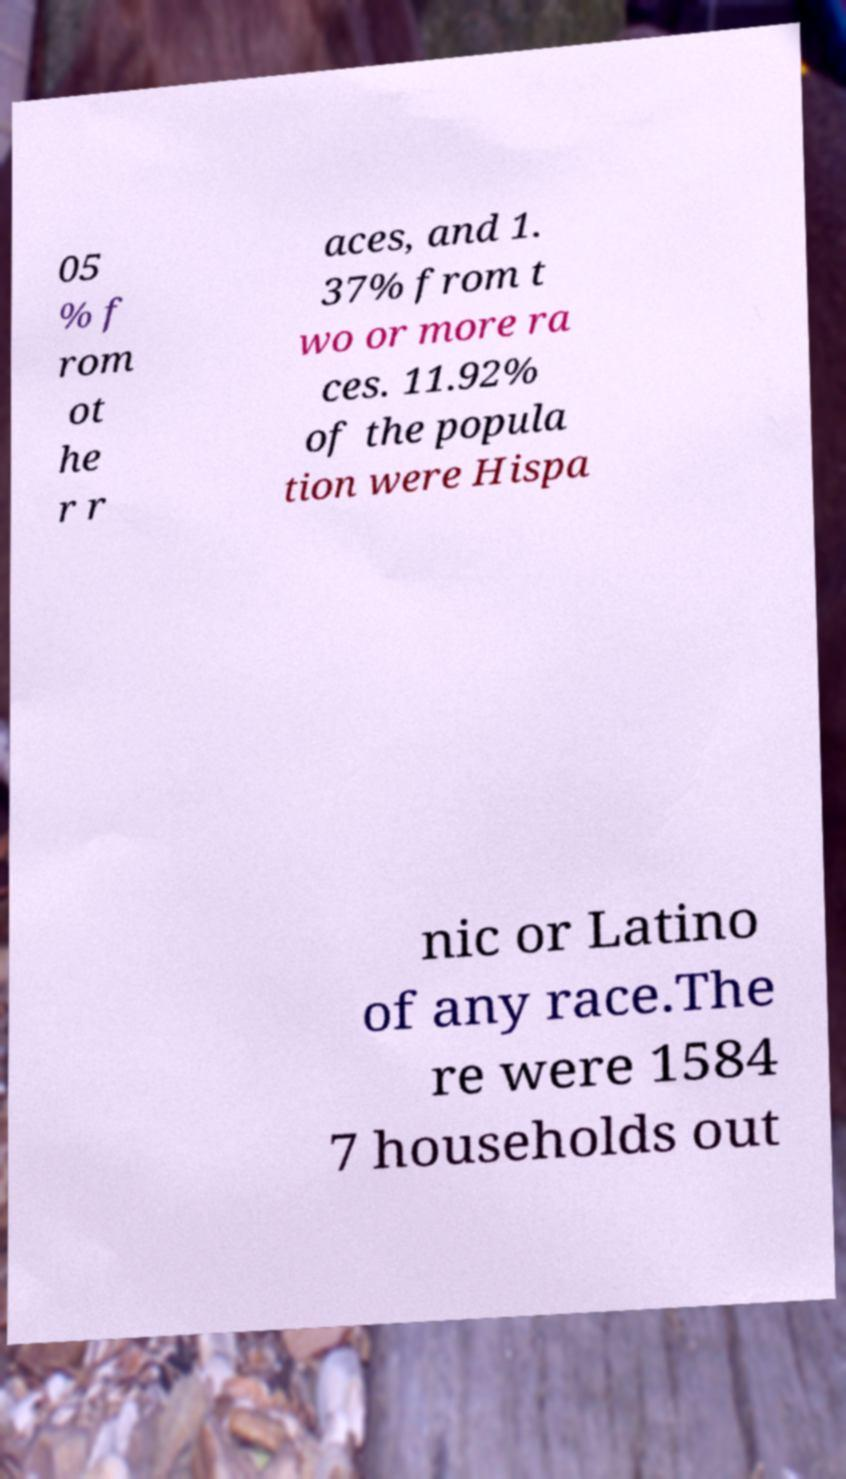For documentation purposes, I need the text within this image transcribed. Could you provide that? 05 % f rom ot he r r aces, and 1. 37% from t wo or more ra ces. 11.92% of the popula tion were Hispa nic or Latino of any race.The re were 1584 7 households out 